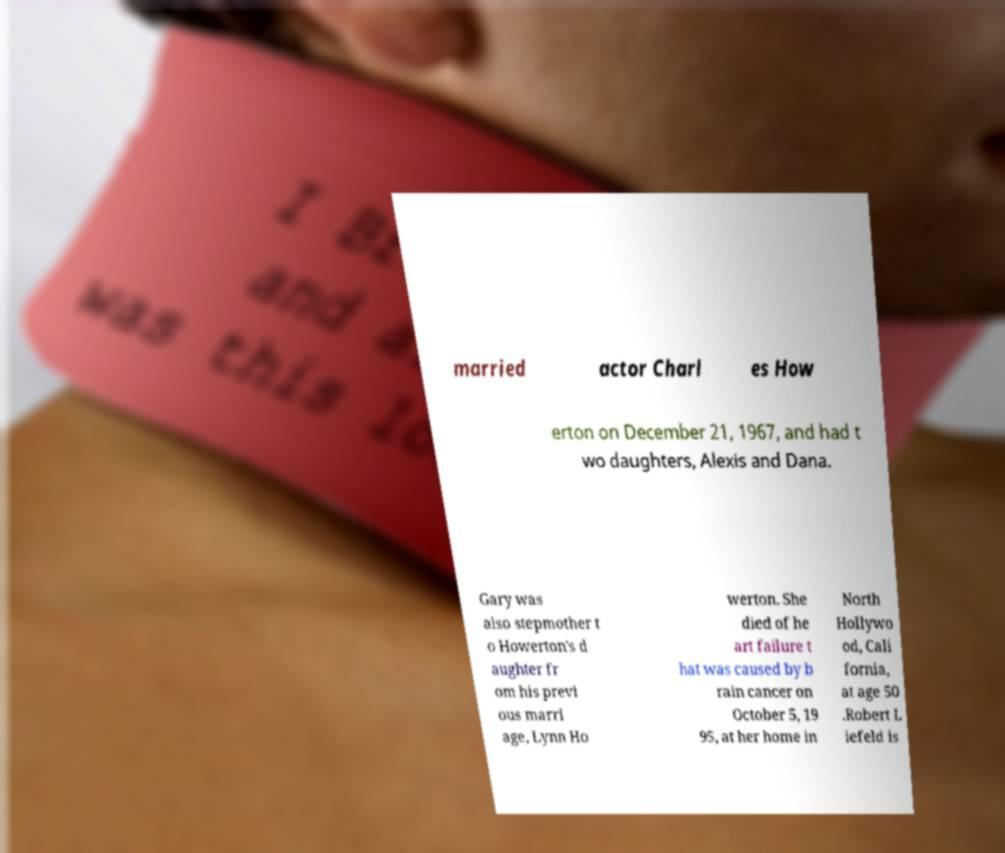Please identify and transcribe the text found in this image. married actor Charl es How erton on December 21, 1967, and had t wo daughters, Alexis and Dana. Gary was also stepmother t o Howerton's d aughter fr om his previ ous marri age, Lynn Ho werton. She died of he art failure t hat was caused by b rain cancer on October 5, 19 95, at her home in North Hollywo od, Cali fornia, at age 50 .Robert L iefeld is 